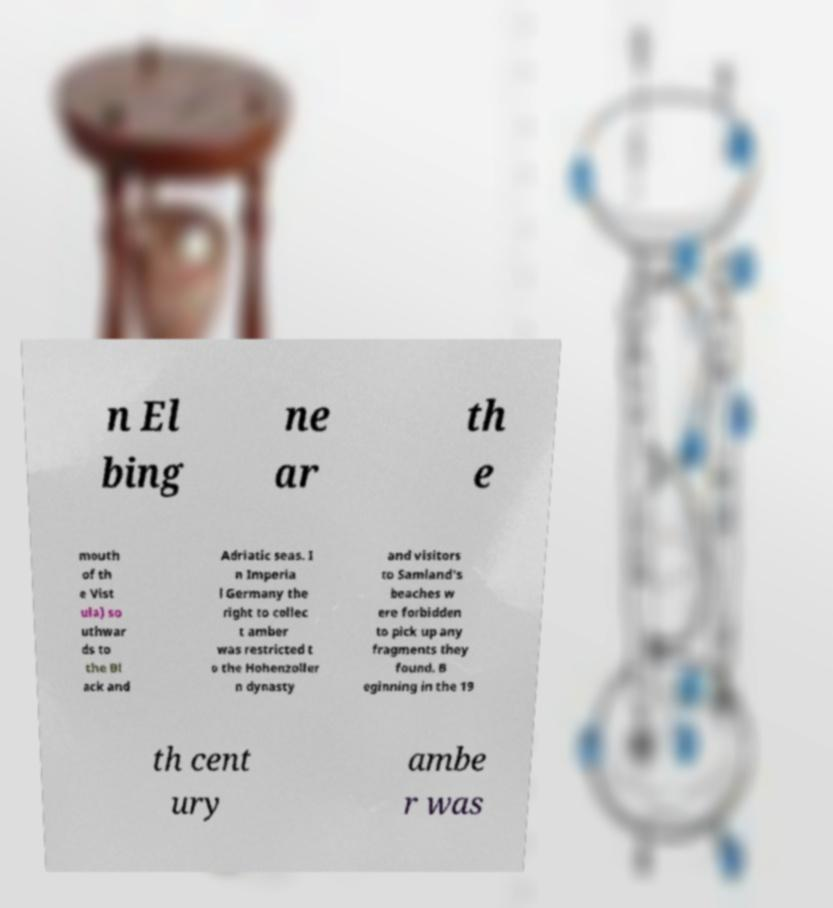Could you extract and type out the text from this image? n El bing ne ar th e mouth of th e Vist ula) so uthwar ds to the Bl ack and Adriatic seas. I n Imperia l Germany the right to collec t amber was restricted t o the Hohenzoller n dynasty and visitors to Samland's beaches w ere forbidden to pick up any fragments they found. B eginning in the 19 th cent ury ambe r was 